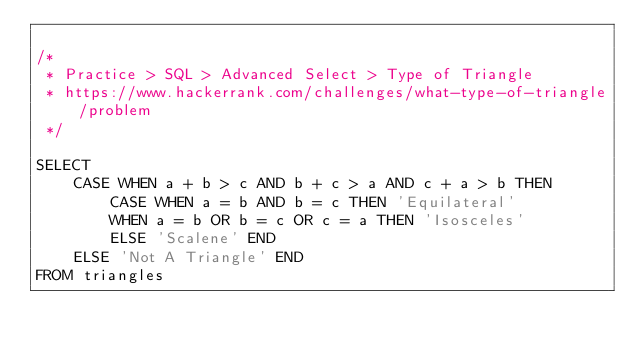Convert code to text. <code><loc_0><loc_0><loc_500><loc_500><_SQL_>
/*
 * Practice > SQL > Advanced Select > Type of Triangle
 * https://www.hackerrank.com/challenges/what-type-of-triangle/problem
 */

SELECT
    CASE WHEN a + b > c AND b + c > a AND c + a > b THEN
        CASE WHEN a = b AND b = c THEN 'Equilateral'
        WHEN a = b OR b = c OR c = a THEN 'Isosceles'
        ELSE 'Scalene' END
    ELSE 'Not A Triangle' END
FROM triangles
</code> 